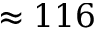<formula> <loc_0><loc_0><loc_500><loc_500>\approx 1 1 6</formula> 